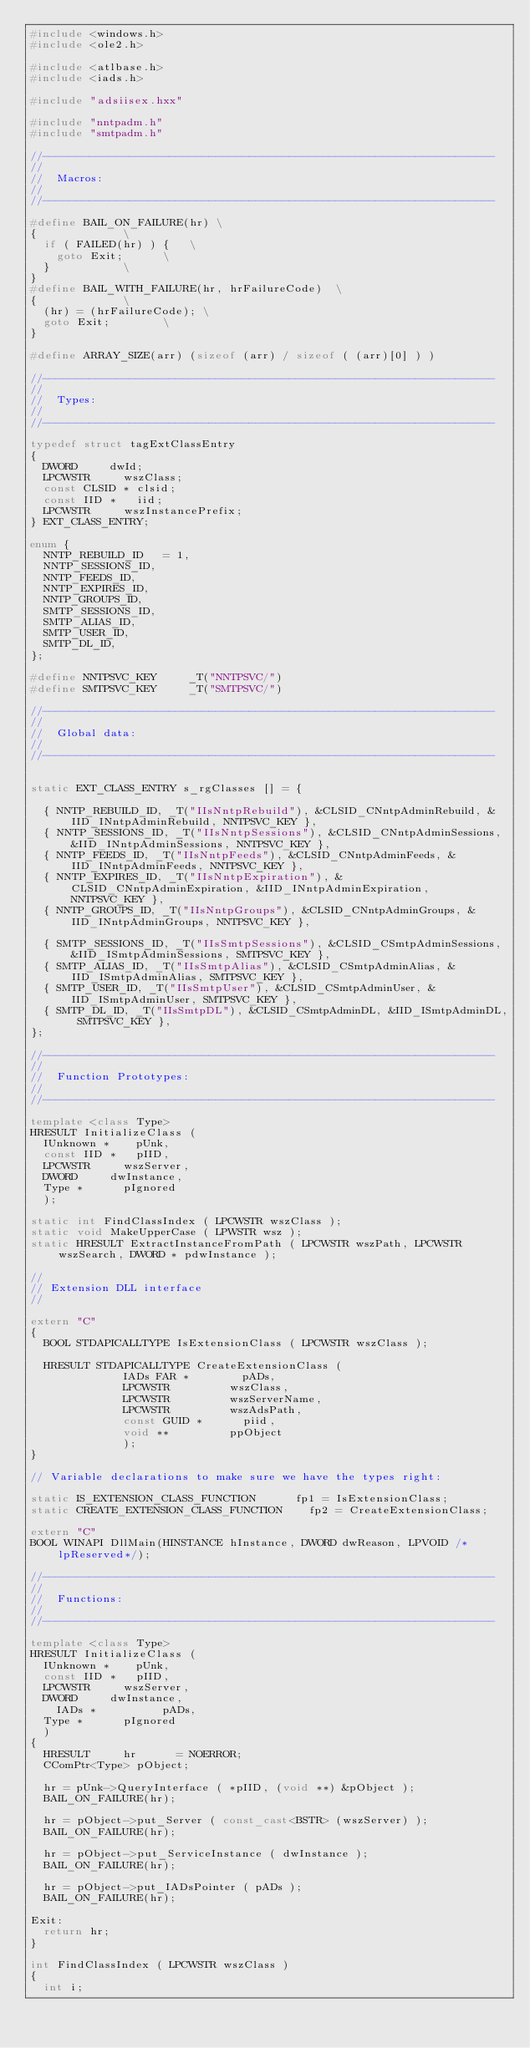Convert code to text. <code><loc_0><loc_0><loc_500><loc_500><_C++_>#include <windows.h>
#include <ole2.h>

#include <atlbase.h>
#include <iads.h>

#include "adsiisex.hxx"

#include "nntpadm.h"
#include "smtpadm.h"

//--------------------------------------------------------------------
//
//	Macros:
//
//--------------------------------------------------------------------

#define BAIL_ON_FAILURE(hr)	\
{							\
	if ( FAILED(hr) ) {		\
		goto Exit;			\
	}						\
}
#define BAIL_WITH_FAILURE(hr, hrFailureCode)	\
{							\
	(hr) = (hrFailureCode);	\
	goto Exit;				\
}

#define ARRAY_SIZE(arr) (sizeof (arr) / sizeof ( (arr)[0] ) )

//--------------------------------------------------------------------
//
//	Types:
//
//--------------------------------------------------------------------

typedef struct tagExtClassEntry
{
	DWORD			dwId;
	LPCWSTR			wszClass;
	const CLSID *	clsid;
	const IID *		iid;
	LPCWSTR			wszInstancePrefix;
} EXT_CLASS_ENTRY;

enum {
	NNTP_REBUILD_ID		= 1,
	NNTP_SESSIONS_ID,
	NNTP_FEEDS_ID,
	NNTP_EXPIRES_ID,
	NNTP_GROUPS_ID,
	SMTP_SESSIONS_ID,
	SMTP_ALIAS_ID,
	SMTP_USER_ID,
	SMTP_DL_ID,
};

#define NNTPSVC_KEY     _T("NNTPSVC/")
#define SMTPSVC_KEY     _T("SMTPSVC/")

//--------------------------------------------------------------------
//
//	Global data:
//
//--------------------------------------------------------------------


static EXT_CLASS_ENTRY s_rgClasses [] = {

	{ NNTP_REBUILD_ID, _T("IIsNntpRebuild"), &CLSID_CNntpAdminRebuild, &IID_INntpAdminRebuild, NNTPSVC_KEY },
	{ NNTP_SESSIONS_ID, _T("IIsNntpSessions"), &CLSID_CNntpAdminSessions, &IID_INntpAdminSessions, NNTPSVC_KEY },
	{ NNTP_FEEDS_ID, _T("IIsNntpFeeds"), &CLSID_CNntpAdminFeeds, &IID_INntpAdminFeeds, NNTPSVC_KEY },
	{ NNTP_EXPIRES_ID, _T("IIsNntpExpiration"), &CLSID_CNntpAdminExpiration, &IID_INntpAdminExpiration, NNTPSVC_KEY },
	{ NNTP_GROUPS_ID, _T("IIsNntpGroups"), &CLSID_CNntpAdminGroups, &IID_INntpAdminGroups, NNTPSVC_KEY },

	{ SMTP_SESSIONS_ID, _T("IIsSmtpSessions"), &CLSID_CSmtpAdminSessions, &IID_ISmtpAdminSessions, SMTPSVC_KEY },
	{ SMTP_ALIAS_ID, _T("IIsSmtpAlias"), &CLSID_CSmtpAdminAlias, &IID_ISmtpAdminAlias, SMTPSVC_KEY },
	{ SMTP_USER_ID, _T("IIsSmtpUser"), &CLSID_CSmtpAdminUser, &IID_ISmtpAdminUser, SMTPSVC_KEY },
	{ SMTP_DL_ID, _T("IIsSmtpDL"), &CLSID_CSmtpAdminDL, &IID_ISmtpAdminDL, SMTPSVC_KEY },
};

//--------------------------------------------------------------------
//
//	Function Prototypes:
//
//--------------------------------------------------------------------

template <class Type>
HRESULT InitializeClass ( 
	IUnknown *		pUnk, 
	const IID *		pIID, 
	LPCWSTR			wszServer, 
	DWORD			dwInstance,
	Type *			pIgnored
	);

static int FindClassIndex ( LPCWSTR wszClass );
static void MakeUpperCase ( LPWSTR wsz );
static HRESULT ExtractInstanceFromPath ( LPCWSTR wszPath, LPCWSTR wszSearch, DWORD * pdwInstance );

//
// Extension DLL interface
//

extern "C"
{
	BOOL STDAPICALLTYPE IsExtensionClass ( LPCWSTR wszClass );

	HRESULT STDAPICALLTYPE CreateExtensionClass ( 
							IADs FAR *				pADs,
							LPCWSTR					wszClass,
							LPCWSTR					wszServerName,
							LPCWSTR					wszAdsPath,
							const GUID *			piid,
							void **					ppObject
							);
}

// Variable declarations to make sure we have the types right:

static IS_EXTENSION_CLASS_FUNCTION			fp1 = IsExtensionClass;
static CREATE_EXTENSION_CLASS_FUNCTION		fp2 = CreateExtensionClass;

extern "C"
BOOL WINAPI DllMain(HINSTANCE hInstance, DWORD dwReason, LPVOID /*lpReserved*/);

//--------------------------------------------------------------------
//
//	Functions:
//
//--------------------------------------------------------------------

template <class Type>
HRESULT InitializeClass ( 
	IUnknown *		pUnk, 
	const IID *		pIID, 
	LPCWSTR			wszServer, 
	DWORD			dwInstance,
    IADs *          pADs,
	Type *			pIgnored
	)
{
	HRESULT			hr			= NOERROR;
	CComPtr<Type>	pObject;

	hr = pUnk->QueryInterface ( *pIID, (void **) &pObject );
	BAIL_ON_FAILURE(hr);

	hr = pObject->put_Server ( const_cast<BSTR> (wszServer) );
	BAIL_ON_FAILURE(hr);

	hr = pObject->put_ServiceInstance ( dwInstance );
	BAIL_ON_FAILURE(hr);

	hr = pObject->put_IADsPointer ( pADs );
	BAIL_ON_FAILURE(hr);

Exit:
	return hr;
}

int FindClassIndex ( LPCWSTR wszClass )
{
	int i;
</code> 